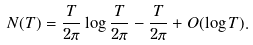Convert formula to latex. <formula><loc_0><loc_0><loc_500><loc_500>N ( T ) = \frac { T } { 2 \pi } \log \frac { T } { 2 \pi } - \frac { T } { 2 \pi } + O ( \log T ) .</formula> 